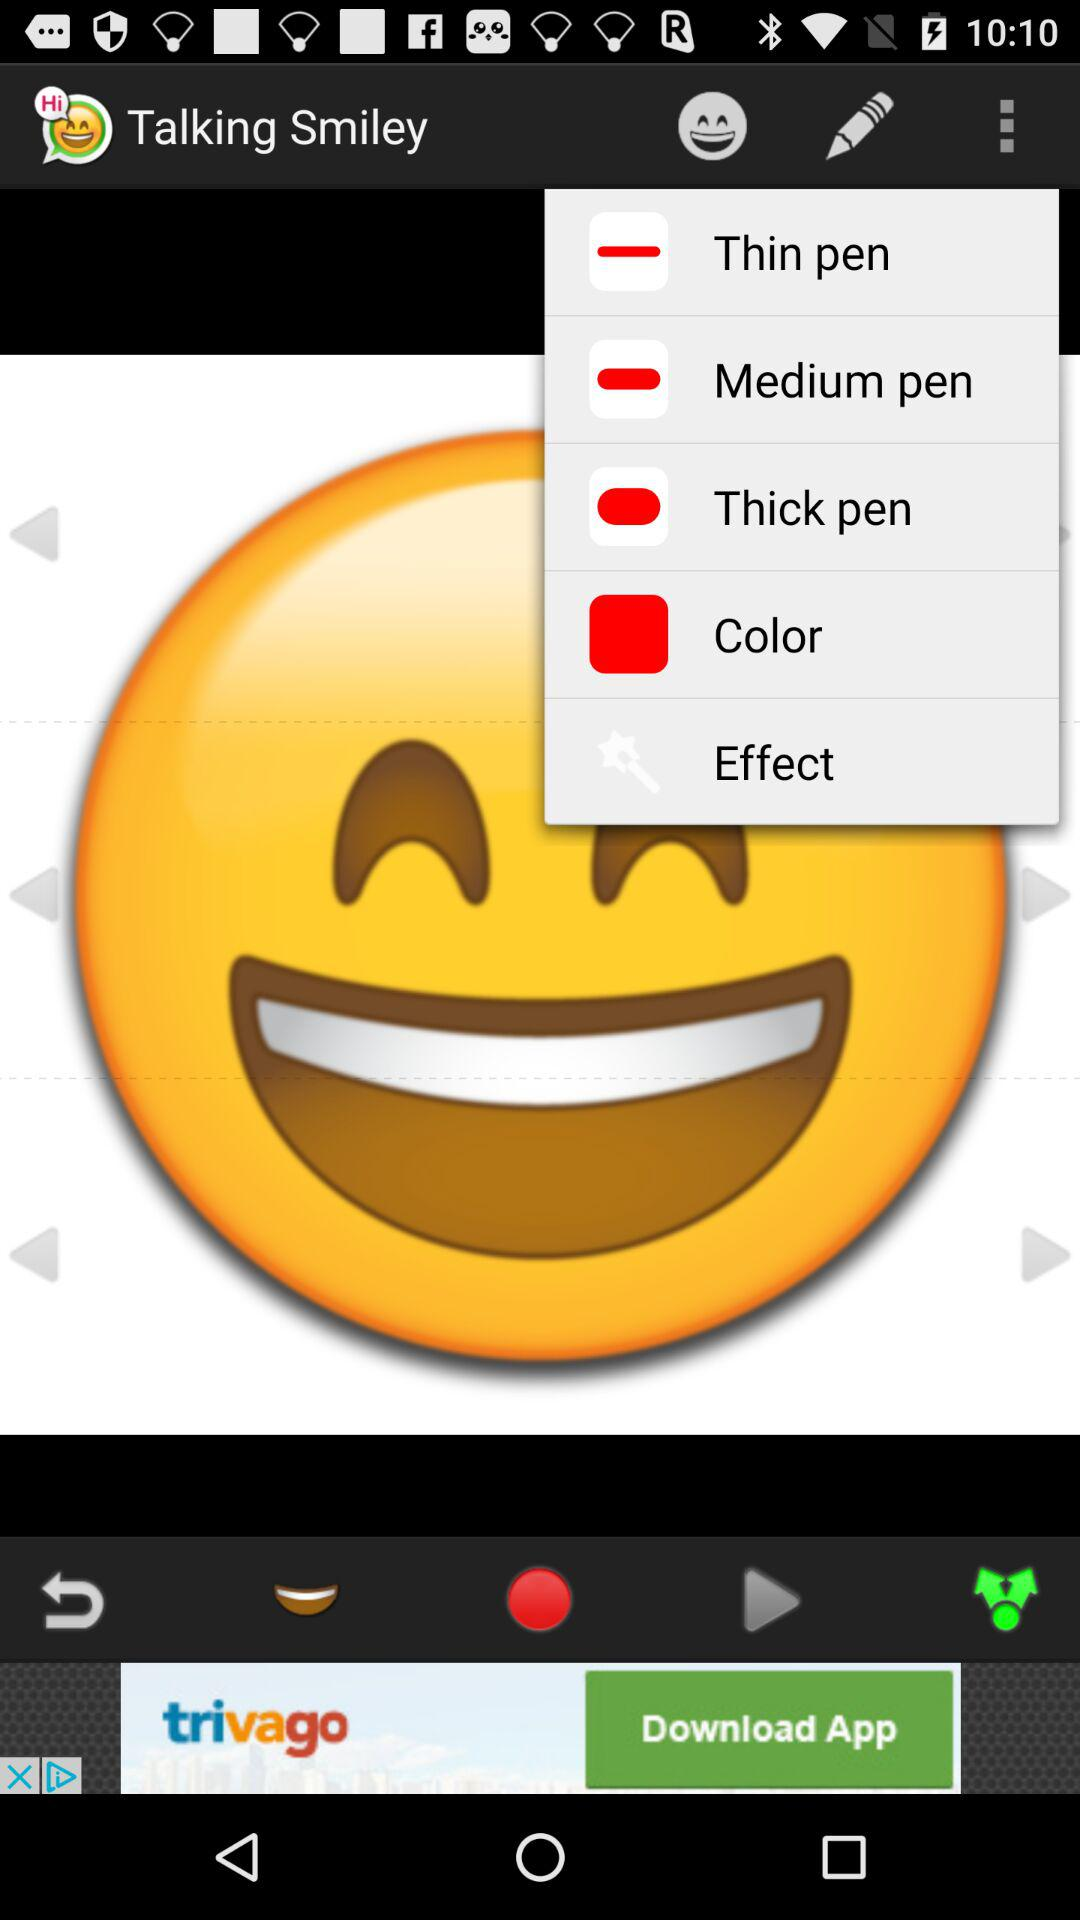What is the app name? The app name is "Talking Smiley". 